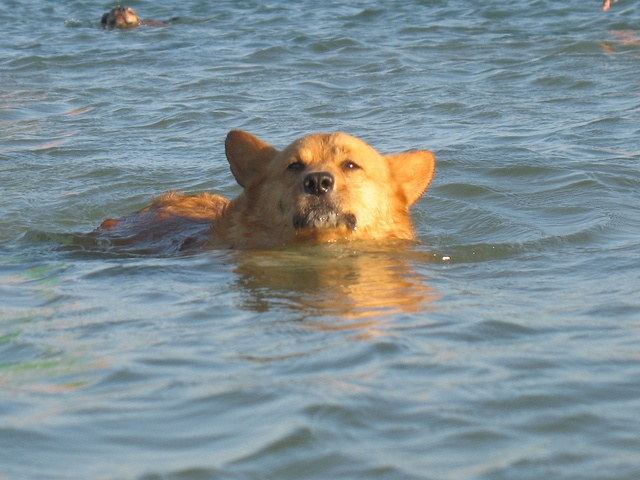Describe the objects in this image and their specific colors. I can see a dog in gray, maroon, and orange tones in this image. 